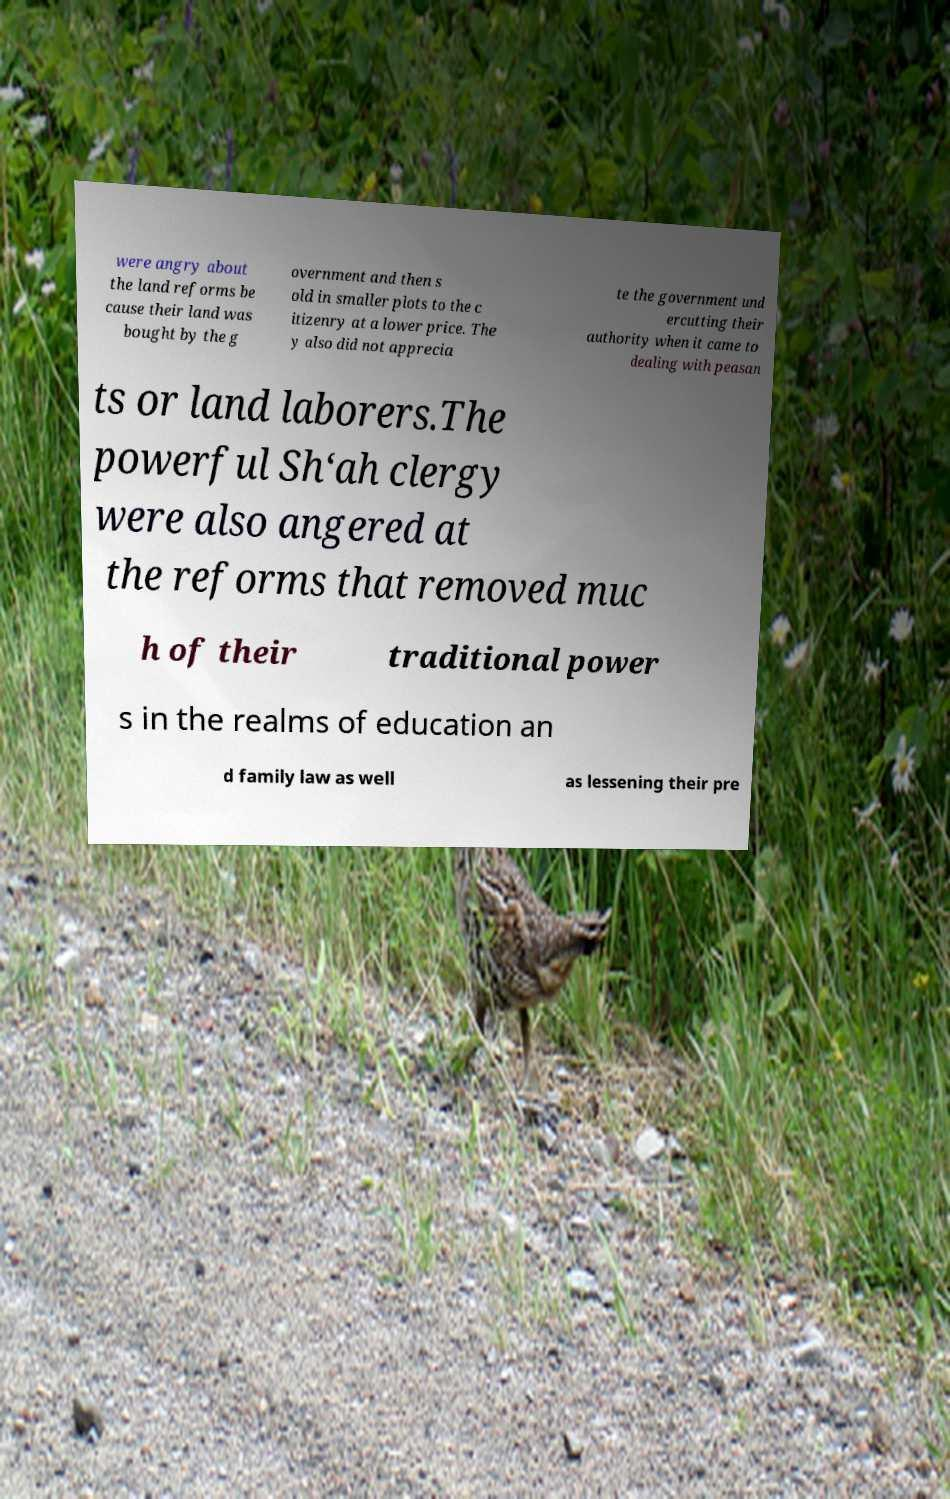What messages or text are displayed in this image? I need them in a readable, typed format. were angry about the land reforms be cause their land was bought by the g overnment and then s old in smaller plots to the c itizenry at a lower price. The y also did not apprecia te the government und ercutting their authority when it came to dealing with peasan ts or land laborers.The powerful Sh‘ah clergy were also angered at the reforms that removed muc h of their traditional power s in the realms of education an d family law as well as lessening their pre 